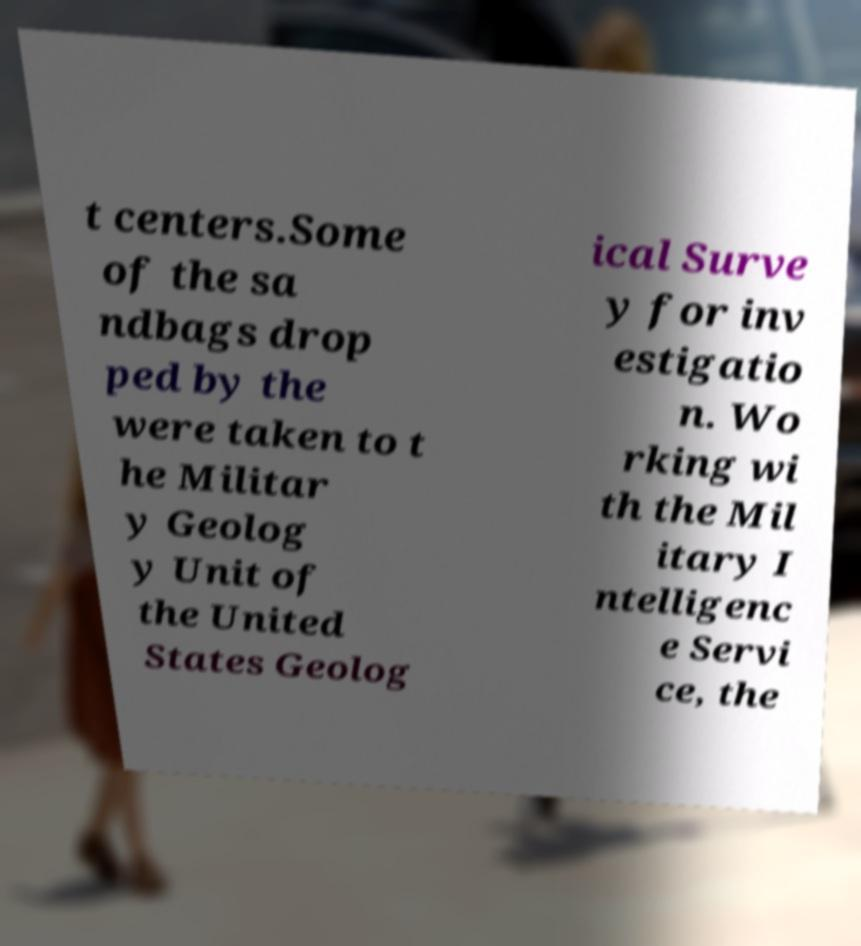Can you read and provide the text displayed in the image?This photo seems to have some interesting text. Can you extract and type it out for me? t centers.Some of the sa ndbags drop ped by the were taken to t he Militar y Geolog y Unit of the United States Geolog ical Surve y for inv estigatio n. Wo rking wi th the Mil itary I ntelligenc e Servi ce, the 